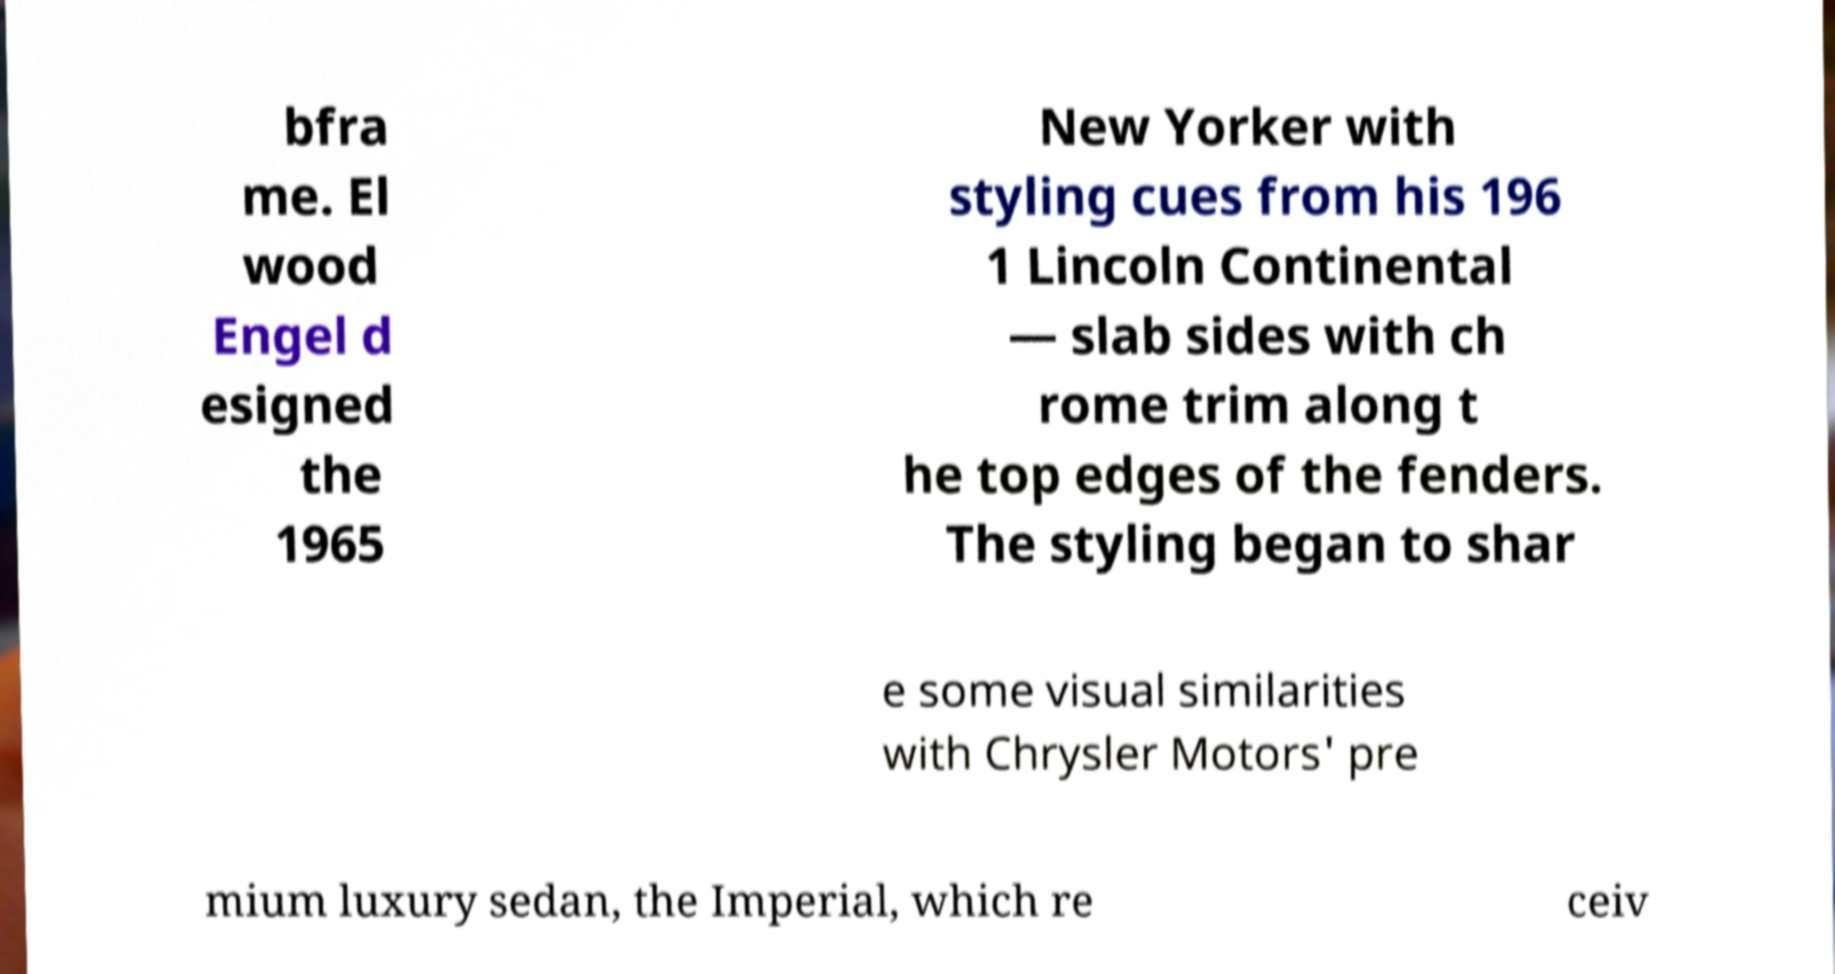I need the written content from this picture converted into text. Can you do that? bfra me. El wood Engel d esigned the 1965 New Yorker with styling cues from his 196 1 Lincoln Continental — slab sides with ch rome trim along t he top edges of the fenders. The styling began to shar e some visual similarities with Chrysler Motors' pre mium luxury sedan, the Imperial, which re ceiv 